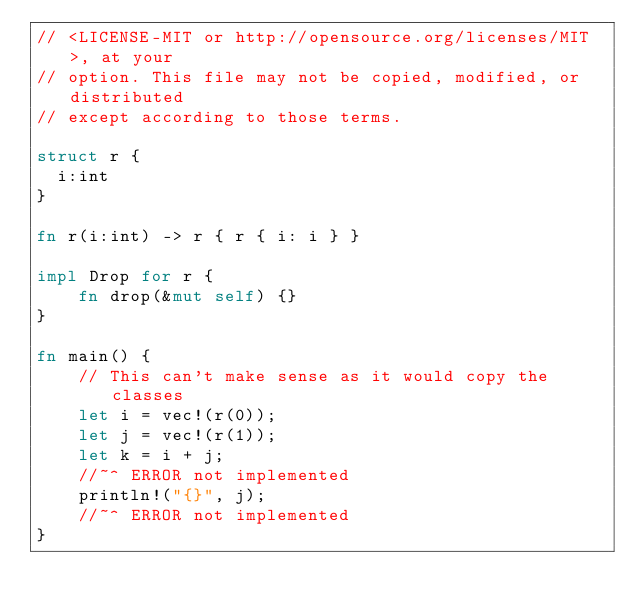<code> <loc_0><loc_0><loc_500><loc_500><_Rust_>// <LICENSE-MIT or http://opensource.org/licenses/MIT>, at your
// option. This file may not be copied, modified, or distributed
// except according to those terms.

struct r {
  i:int
}

fn r(i:int) -> r { r { i: i } }

impl Drop for r {
    fn drop(&mut self) {}
}

fn main() {
    // This can't make sense as it would copy the classes
    let i = vec!(r(0));
    let j = vec!(r(1));
    let k = i + j;
    //~^ ERROR not implemented
    println!("{}", j);
    //~^ ERROR not implemented
}
</code> 